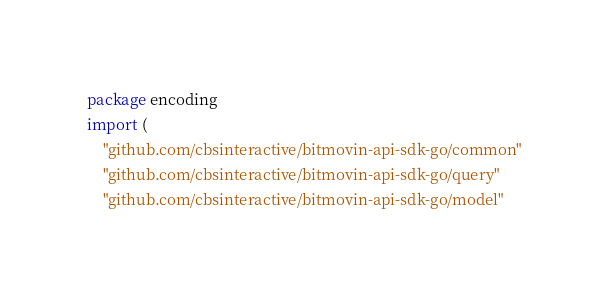Convert code to text. <code><loc_0><loc_0><loc_500><loc_500><_Go_>package encoding
import (
    "github.com/cbsinteractive/bitmovin-api-sdk-go/common"
    "github.com/cbsinteractive/bitmovin-api-sdk-go/query"
    "github.com/cbsinteractive/bitmovin-api-sdk-go/model"</code> 